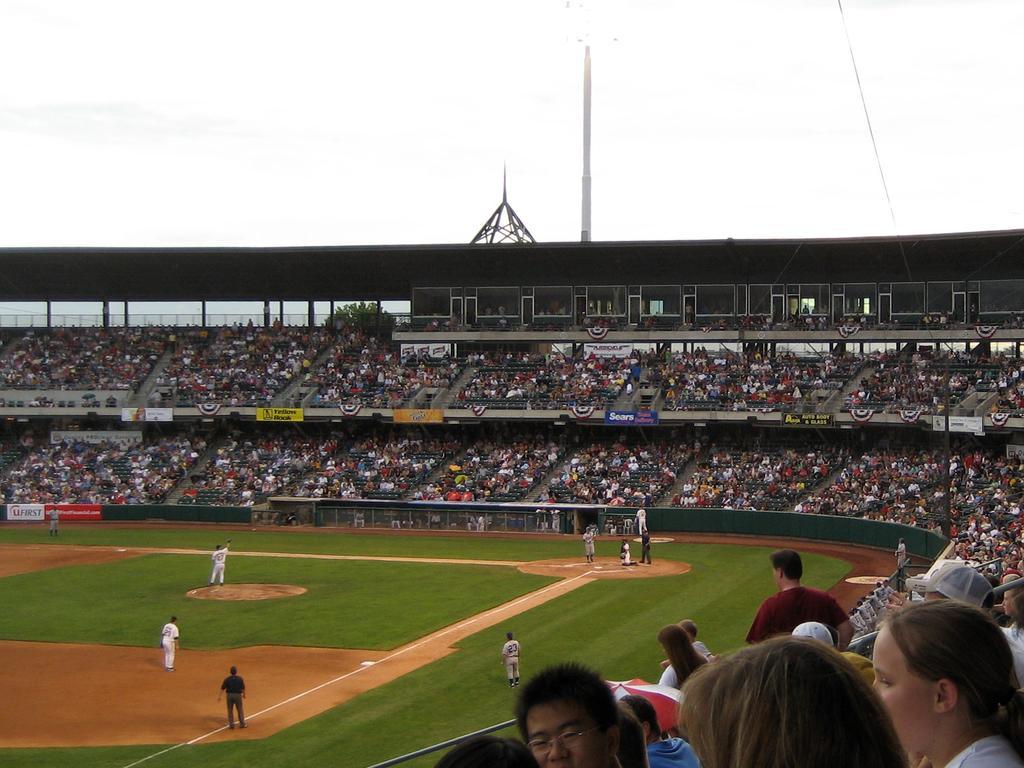Could you give a brief overview of what you see in this image? This picture is taken in the stadium. In this image, on the right side, we can see a group of people sitting on the chair, we can also see a few people are standing. On the right side, we can also see a staircase. In the middle of the image, we can also see a group of people are playing the game. At the top, we can see a pole and a sky. At the bottom, we can see a grass and a land with some stones. 